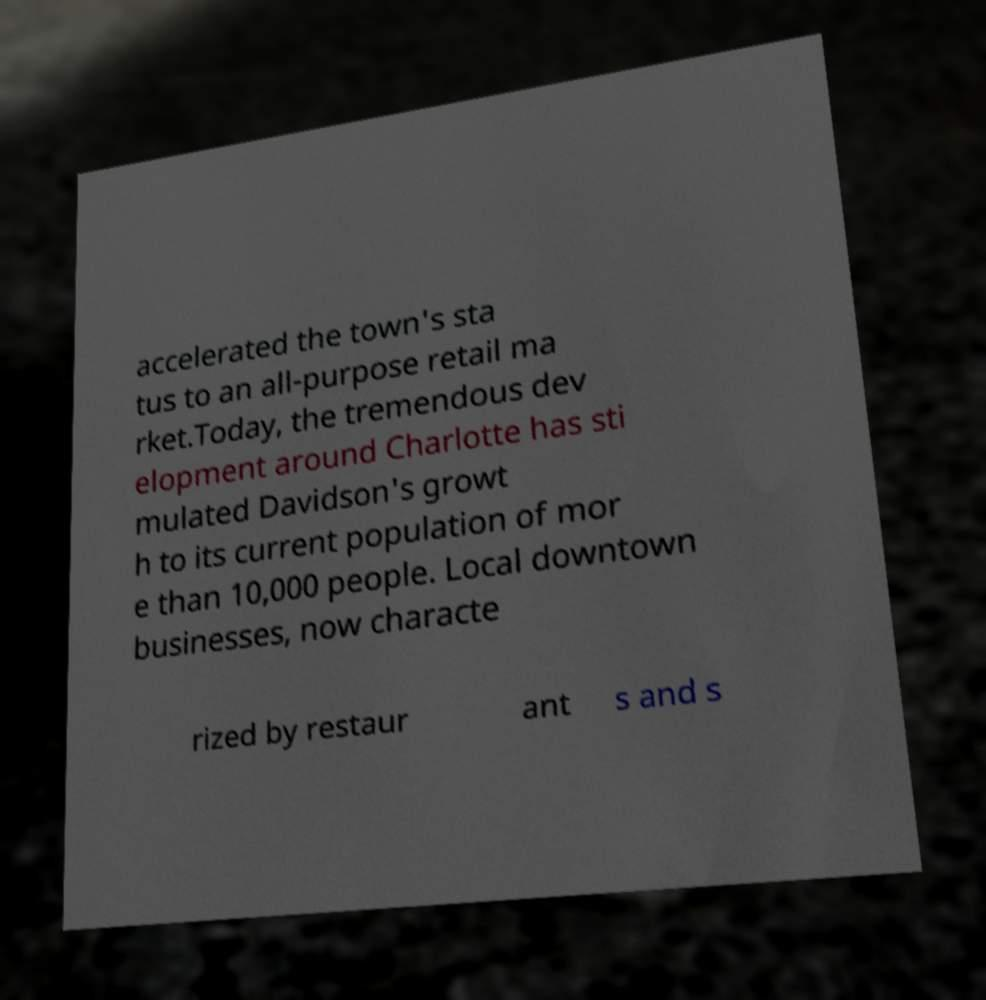Please read and relay the text visible in this image. What does it say? accelerated the town's sta tus to an all-purpose retail ma rket.Today, the tremendous dev elopment around Charlotte has sti mulated Davidson's growt h to its current population of mor e than 10,000 people. Local downtown businesses, now characte rized by restaur ant s and s 